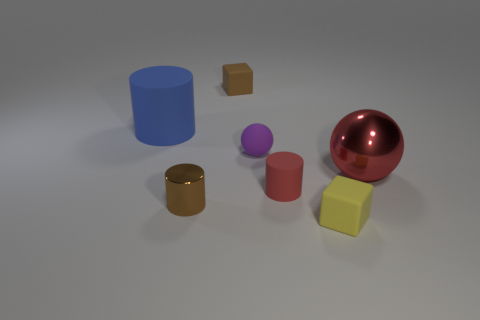Is the number of tiny red objects less than the number of small cyan metal blocks?
Make the answer very short. No. What shape is the brown thing in front of the ball that is behind the big ball?
Make the answer very short. Cylinder. There is a metallic object that is the same size as the matte ball; what is its shape?
Offer a very short reply. Cylinder. Are there any blue things that have the same shape as the large red thing?
Your answer should be very brief. No. What is the tiny brown cube made of?
Provide a succinct answer. Rubber. Are there any blue matte cylinders in front of the big red shiny thing?
Your answer should be very brief. No. There is a tiny rubber cube that is behind the yellow rubber object; how many tiny shiny things are left of it?
Keep it short and to the point. 1. What is the material of the red cylinder that is the same size as the purple matte object?
Ensure brevity in your answer.  Rubber. How many other things are there of the same material as the big blue thing?
Ensure brevity in your answer.  4. There is a big matte object; how many small spheres are in front of it?
Provide a short and direct response. 1. 